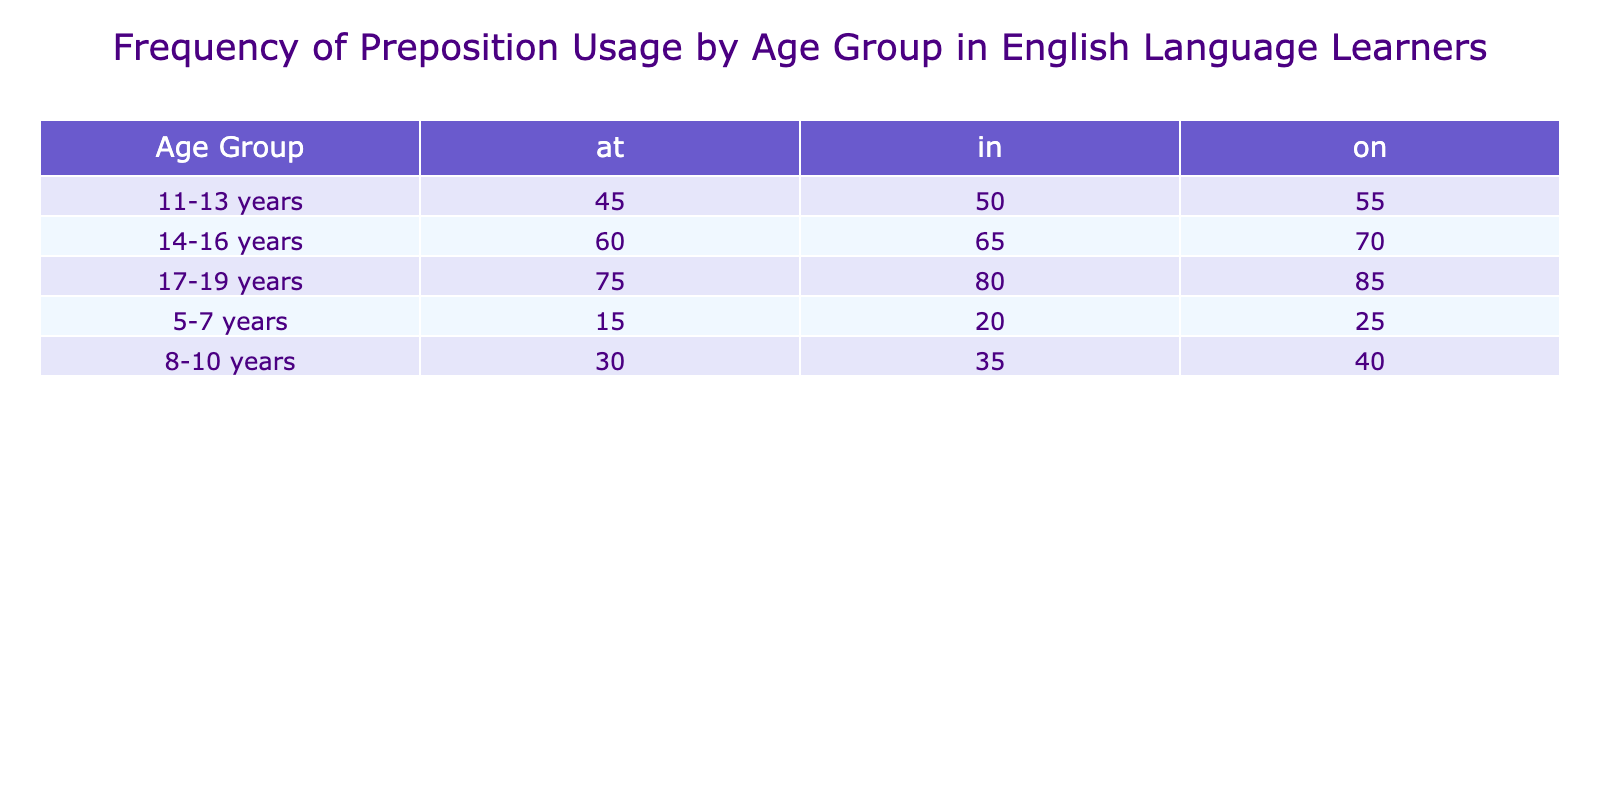What is the frequency of the preposition "in" for the age group 14-16 years? According to the table, the frequency of the preposition "in" for the age group 14-16 years is directly stated as 65.
Answer: 65 What is the total frequency of all prepositions used by the age group 11-13 years? The frequencies for the age group 11-13 years are: at (45), in (50), and on (55). Adding these gives a total of 45 + 50 + 55 = 150.
Answer: 150 Is the frequency of the preposition "at" higher for the age group 17-19 years than for the age group 5-7 years? The frequency of "at" for 17-19 years is 75, while for 5-7 years it is 15. Since 75 is greater than 15, the statement is true.
Answer: Yes What is the average frequency of the preposition "on" across all age groups? The frequencies for the preposition "on" are: 25 (5-7 years), 40 (8-10 years), 55 (11-13 years), 70 (14-16 years), and 85 (17-19 years). The total is 25 + 40 + 55 + 70 + 85 = 275, and there are 5 age groups, so the average is 275/5 = 55.
Answer: 55 Which age group shows the highest frequency for the preposition "in"? Reviewing the values for the preposition "in", we find: 20 (5-7 years), 35 (8-10 years), 50 (11-13 years), 65 (14-16 years), and 80 (17-19 years). Among these, the highest value is 80 for the age group 17-19 years.
Answer: 17-19 years What is the difference in frequency of the preposition "on" between the age groups 8-10 years and 14-16 years? The frequency for "on" for 8-10 years is 40 and for 14-16 years is 70. The difference is calculated as 70 - 40 = 30.
Answer: 30 Is the total frequency of the preposition "at" greater than or equal to the total frequency of the preposition "in"? The total frequency for "at" across all age groups is 15 + 30 + 45 + 60 + 75 = 225. The total frequency for "in" is 20 + 35 + 50 + 65 + 80 = 250. Since 225 is less than 250, the statement is false.
Answer: No Which preposition is most frequently used by the age group 8-10 years? The frequencies for the age group 8-10 years are: at (30), in (35), and on (40). The highest frequency is 40 for the preposition "on."
Answer: on 